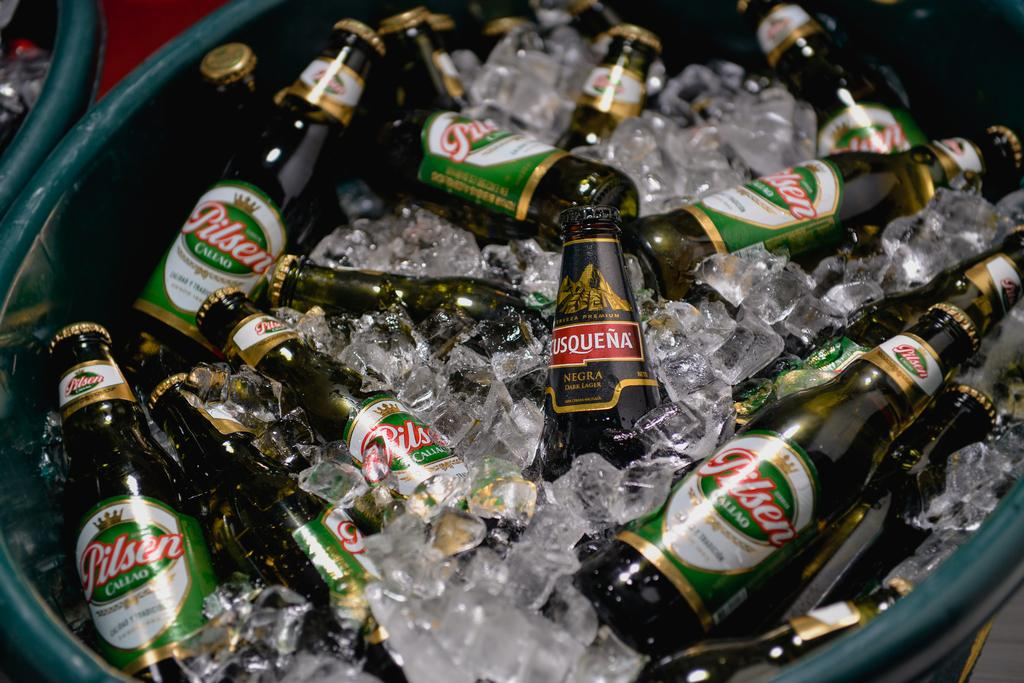<image>
Summarize the visual content of the image. a cooler full of ice and beer, most of it pilsen with one rusquena bottle in the middle 